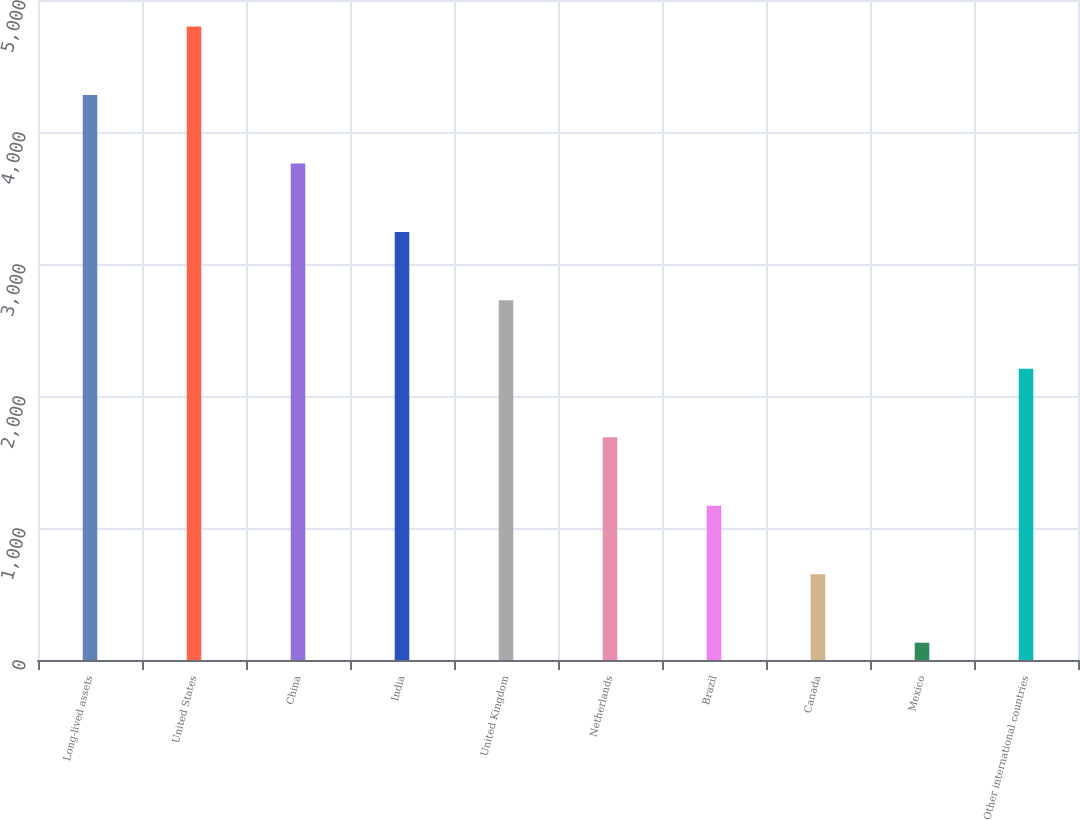Convert chart to OTSL. <chart><loc_0><loc_0><loc_500><loc_500><bar_chart><fcel>Long-lived assets<fcel>United States<fcel>China<fcel>India<fcel>United Kingdom<fcel>Netherlands<fcel>Brazil<fcel>Canada<fcel>Mexico<fcel>Other international countries<nl><fcel>4280.6<fcel>4799.3<fcel>3761.9<fcel>3243.2<fcel>2724.5<fcel>1687.1<fcel>1168.4<fcel>649.7<fcel>131<fcel>2205.8<nl></chart> 